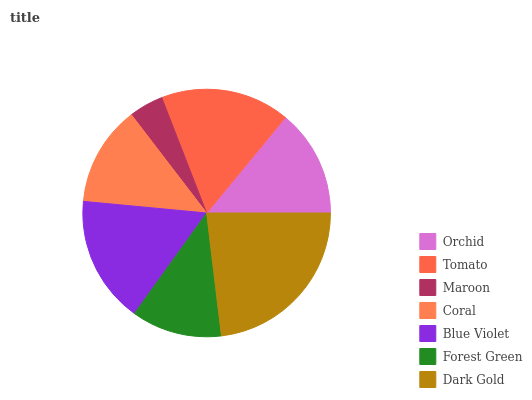Is Maroon the minimum?
Answer yes or no. Yes. Is Dark Gold the maximum?
Answer yes or no. Yes. Is Tomato the minimum?
Answer yes or no. No. Is Tomato the maximum?
Answer yes or no. No. Is Tomato greater than Orchid?
Answer yes or no. Yes. Is Orchid less than Tomato?
Answer yes or no. Yes. Is Orchid greater than Tomato?
Answer yes or no. No. Is Tomato less than Orchid?
Answer yes or no. No. Is Orchid the high median?
Answer yes or no. Yes. Is Orchid the low median?
Answer yes or no. Yes. Is Blue Violet the high median?
Answer yes or no. No. Is Coral the low median?
Answer yes or no. No. 